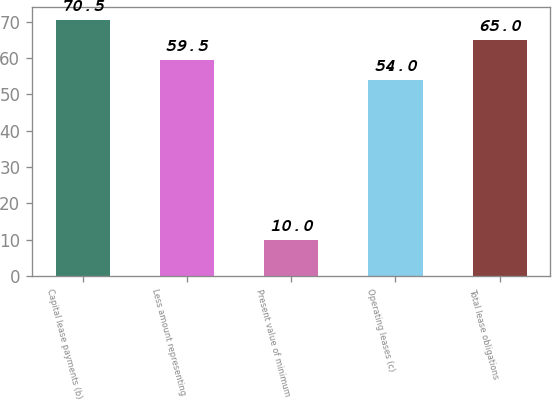<chart> <loc_0><loc_0><loc_500><loc_500><bar_chart><fcel>Capital lease payments (b)<fcel>Less amount representing<fcel>Present value of minimum<fcel>Operating leases (c)<fcel>Total lease obligations<nl><fcel>70.5<fcel>59.5<fcel>10<fcel>54<fcel>65<nl></chart> 